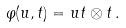<formula> <loc_0><loc_0><loc_500><loc_500>\varphi ( u , t ) = u t \otimes t \, .</formula> 